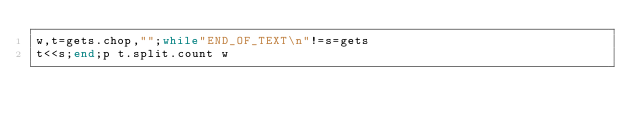Convert code to text. <code><loc_0><loc_0><loc_500><loc_500><_Ruby_>w,t=gets.chop,"";while"END_OF_TEXT\n"!=s=gets
t<<s;end;p t.split.count w</code> 